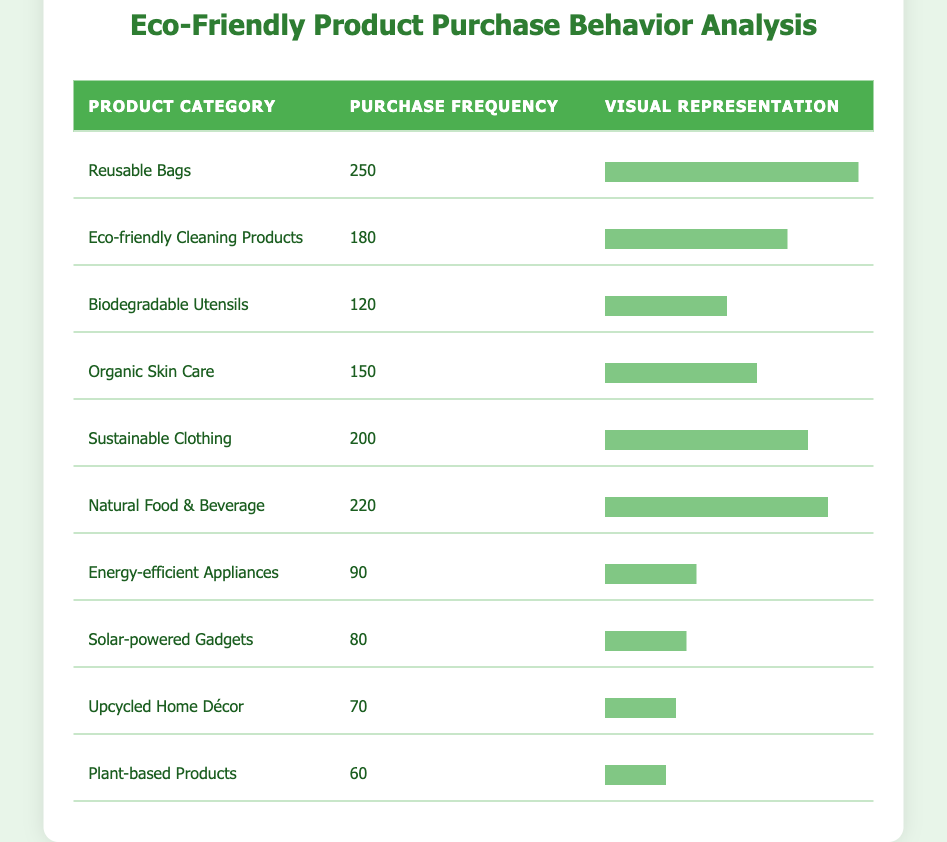What is the purchase frequency of Reusable Bags? The table lists Reusable Bags under the product category. By referring to the purchase frequency column corresponding to Reusable Bags, we can see that it is 250.
Answer: 250 Which product category has the lowest purchase frequency? By scanning the purchase frequency column, we can identify the product categories with the lowest numbers. Upcycled Home Décor has a purchase frequency of 70, which is the smallest amongst all categories listed.
Answer: Upcycled Home Décor What is the total purchase frequency of Sustainable Clothing and Organic Skin Care? To find the total, first identify the purchase frequency for Sustainable Clothing, which is 200, and for Organic Skin Care, which is 150. Adding these two values (200 + 150) gives a total of 350.
Answer: 350 Is the purchase frequency of Eco-friendly Cleaning Products greater than that of Energy-efficient Appliances? Checking the frequencies reveals Eco-friendly Cleaning Products have a frequency of 180, while Energy-efficient Appliances have a frequency of 90. Since 180 is indeed greater than 90, the statement is true.
Answer: Yes What is the average purchase frequency of all product categories listed in the table? First, we need to sum all the frequencies: 250 + 180 + 120 + 150 + 200 + 220 + 90 + 80 + 70 + 60 = 1,520. There are 10 categories, so we divide the total (1,520) by the number of categories (10), which equals 152.
Answer: 152 Which product category has the purchase frequency closest to the average? The average frequency calculated is 152. The purchase frequencies nearest to this value are Organic Skin Care at 150 and Biodegradable Utensils at 120. Organic Skin Care (150) is closer to the average than any others.
Answer: Organic Skin Care How many product categories have a purchase frequency greater than 200? By looking at the table, the product categories with frequencies higher than 200 are Reusable Bags (250), Natural Food & Beverage (220), and Sustainable Clothing (200). However, Sustainable Clothing does not exceed 200. Thus, only Reusable Bags and Natural Food & Beverage qualify, leading to a total of 2 categories.
Answer: 2 What percentage of the total purchases do Solar-powered Gadgets represent? First, add the total purchase frequencies to get 1,520. The purchase frequency for Solar-powered Gadgets is 80. To find the percentage, divide 80 by 1,520 and then multiply by 100, resulting in approximately 5.26%.
Answer: 5.26% 